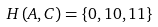Convert formula to latex. <formula><loc_0><loc_0><loc_500><loc_500>H \left ( A , C \right ) = \left \{ 0 , 1 0 , 1 1 \right \}</formula> 